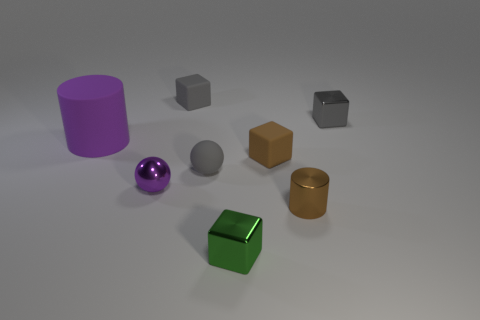Add 1 small blue rubber blocks. How many objects exist? 9 Subtract all balls. How many objects are left? 6 Subtract 1 green cubes. How many objects are left? 7 Subtract all gray matte blocks. Subtract all red balls. How many objects are left? 7 Add 6 tiny cubes. How many tiny cubes are left? 10 Add 2 small cyan shiny cylinders. How many small cyan shiny cylinders exist? 2 